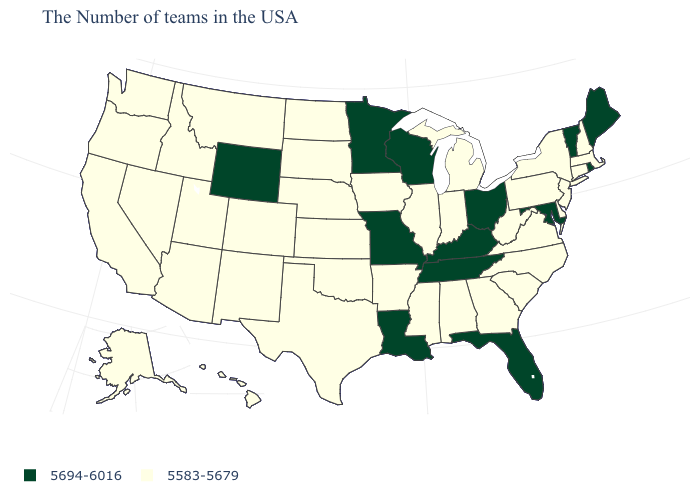What is the lowest value in the USA?
Answer briefly. 5583-5679. How many symbols are there in the legend?
Keep it brief. 2. What is the value of Wisconsin?
Concise answer only. 5694-6016. What is the value of Colorado?
Short answer required. 5583-5679. What is the value of Connecticut?
Short answer required. 5583-5679. Name the states that have a value in the range 5694-6016?
Be succinct. Maine, Rhode Island, Vermont, Maryland, Ohio, Florida, Kentucky, Tennessee, Wisconsin, Louisiana, Missouri, Minnesota, Wyoming. How many symbols are there in the legend?
Write a very short answer. 2. Does Iowa have a lower value than Wyoming?
Short answer required. Yes. Which states have the lowest value in the USA?
Concise answer only. Massachusetts, New Hampshire, Connecticut, New York, New Jersey, Delaware, Pennsylvania, Virginia, North Carolina, South Carolina, West Virginia, Georgia, Michigan, Indiana, Alabama, Illinois, Mississippi, Arkansas, Iowa, Kansas, Nebraska, Oklahoma, Texas, South Dakota, North Dakota, Colorado, New Mexico, Utah, Montana, Arizona, Idaho, Nevada, California, Washington, Oregon, Alaska, Hawaii. Among the states that border New York , which have the lowest value?
Concise answer only. Massachusetts, Connecticut, New Jersey, Pennsylvania. What is the value of Maine?
Answer briefly. 5694-6016. Among the states that border North Dakota , which have the lowest value?
Quick response, please. South Dakota, Montana. What is the value of New Hampshire?
Short answer required. 5583-5679. What is the value of Connecticut?
Short answer required. 5583-5679. Does Michigan have a lower value than Arkansas?
Write a very short answer. No. 